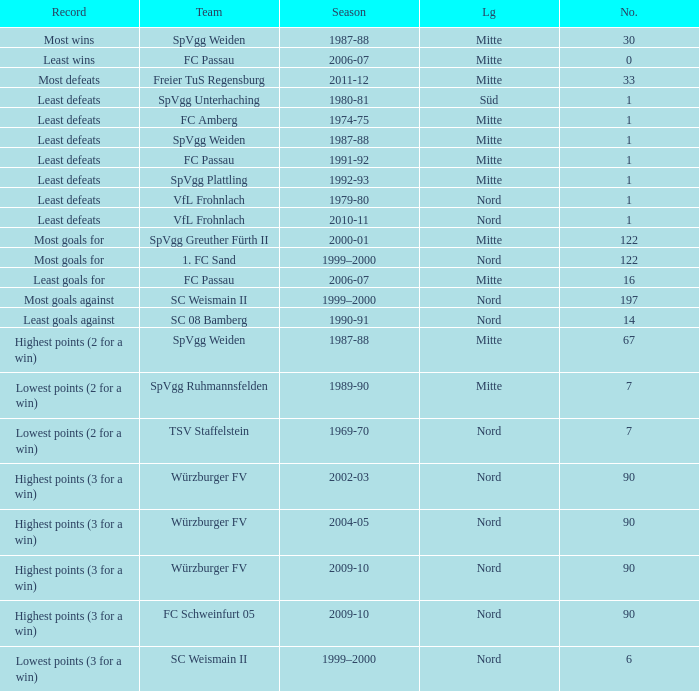What team has 2000-01 as the season? SpVgg Greuther Fürth II. 